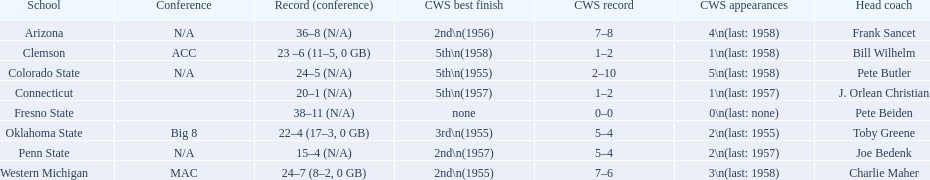What are the teams in the conference? Arizona, Clemson, Colorado State, Connecticut, Fresno State, Oklahoma State, Penn State, Western Michigan. Which have more than 16 wins? Arizona, Clemson, Colorado State, Connecticut, Fresno State, Oklahoma State, Western Michigan. Which had less than 16 wins? Penn State. 